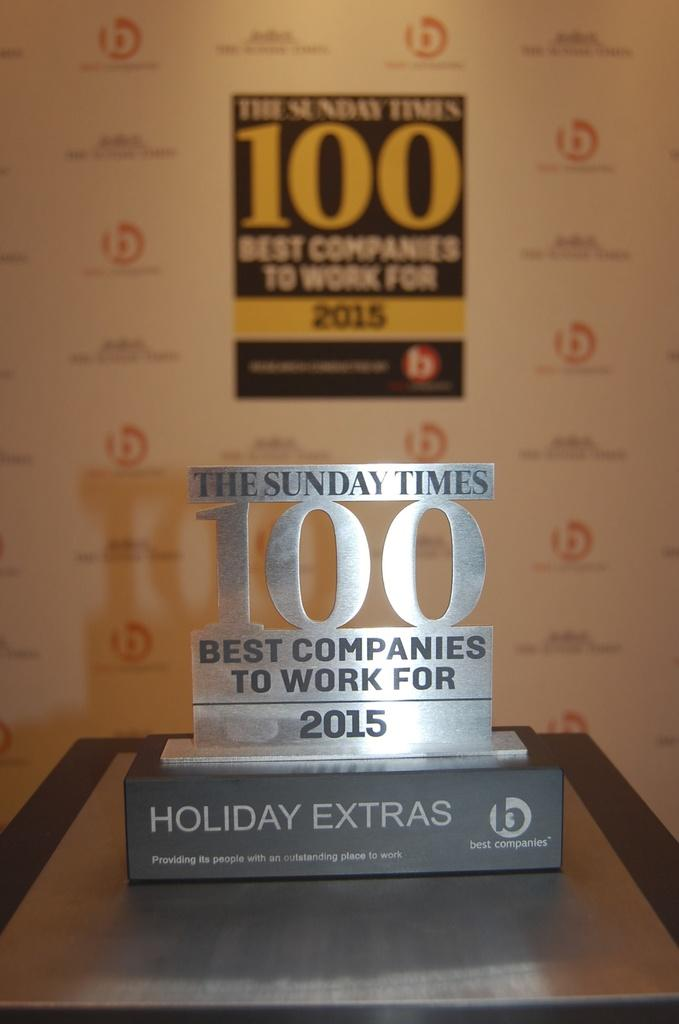<image>
Describe the image concisely. The plaque indicates The Sunday Times is one of the best companies to work for. 